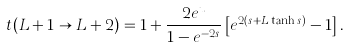<formula> <loc_0><loc_0><loc_500><loc_500>t ( L + 1 \rightarrow L + 2 ) = 1 + \frac { 2 e ^ { u } } { 1 - e ^ { - 2 s } } \left [ e ^ { 2 ( s + L \tanh s ) } - 1 \right ] .</formula> 